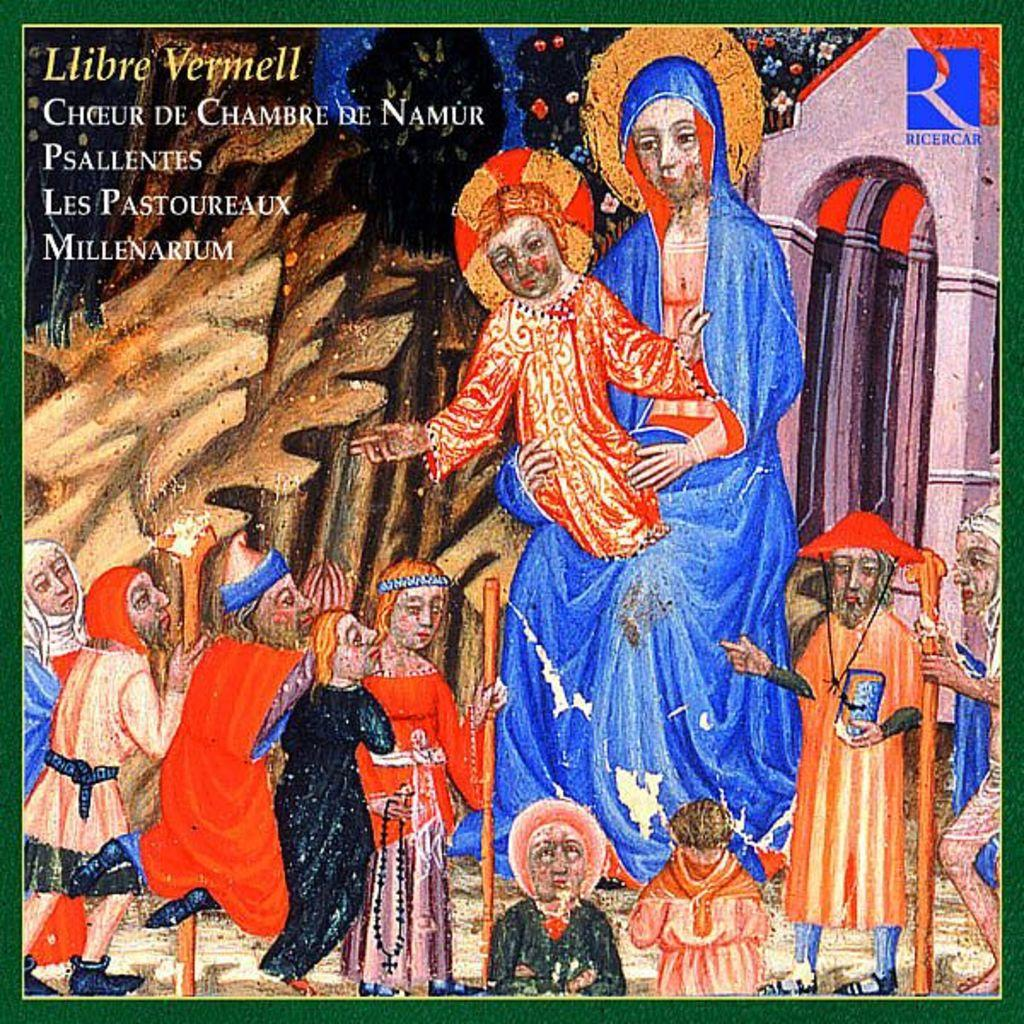What is the main subject of the image? The main subject of the image is a picture. What can be seen in the picture? There are people standing in the picture. How does the yak distribute its weight in the image? There is no yak present in the image, so this question cannot be answered. 